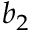Convert formula to latex. <formula><loc_0><loc_0><loc_500><loc_500>b _ { 2 }</formula> 